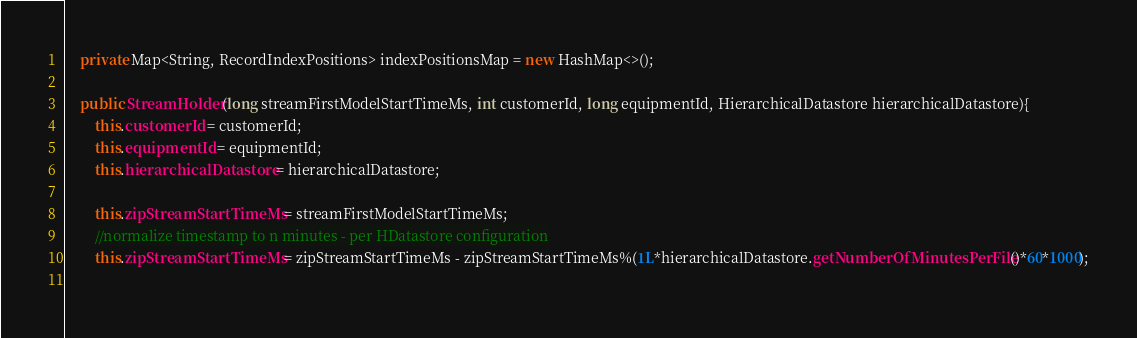<code> <loc_0><loc_0><loc_500><loc_500><_Java_>    private Map<String, RecordIndexPositions> indexPositionsMap = new HashMap<>();
    
    public StreamHolder(long streamFirstModelStartTimeMs, int customerId, long equipmentId, HierarchicalDatastore hierarchicalDatastore){
        this.customerId = customerId;
        this.equipmentId = equipmentId;
        this.hierarchicalDatastore = hierarchicalDatastore;
        
        this.zipStreamStartTimeMs = streamFirstModelStartTimeMs;
        //normalize timestamp to n minutes - per HDatastore configuration
        this.zipStreamStartTimeMs = zipStreamStartTimeMs - zipStreamStartTimeMs%(1L*hierarchicalDatastore.getNumberOfMinutesPerFile()*60*1000);
        </code> 